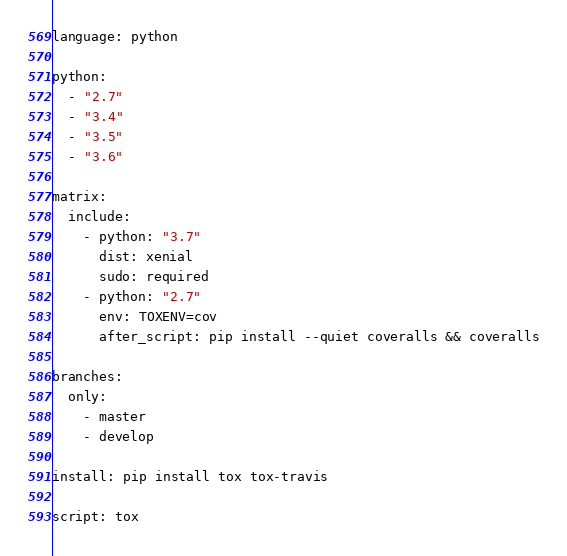Convert code to text. <code><loc_0><loc_0><loc_500><loc_500><_YAML_>language: python

python:
  - "2.7"
  - "3.4"
  - "3.5"
  - "3.6"

matrix:
  include:
    - python: "3.7"
      dist: xenial
      sudo: required
    - python: "2.7"
      env: TOXENV=cov
      after_script: pip install --quiet coveralls && coveralls

branches:
  only:
    - master
    - develop

install: pip install tox tox-travis

script: tox
</code> 